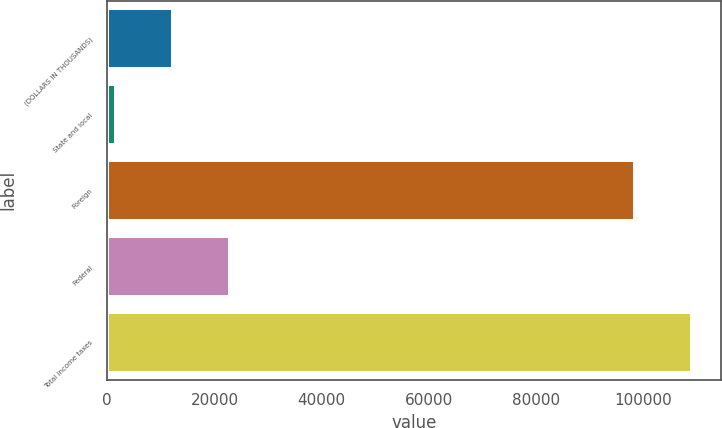Convert chart. <chart><loc_0><loc_0><loc_500><loc_500><bar_chart><fcel>(DOLLARS IN THOUSANDS)<fcel>State and local<fcel>Foreign<fcel>Federal<fcel>Total income taxes<nl><fcel>12335.7<fcel>1709<fcel>98433<fcel>22962.4<fcel>109060<nl></chart> 